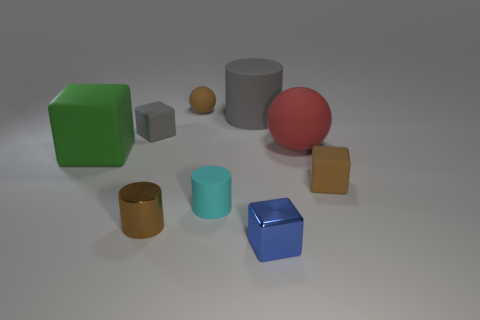Add 1 brown spheres. How many objects exist? 10 Subtract all blocks. How many objects are left? 5 Subtract all blue metallic blocks. Subtract all red objects. How many objects are left? 7 Add 5 large cylinders. How many large cylinders are left? 6 Add 5 yellow blocks. How many yellow blocks exist? 5 Subtract 0 blue cylinders. How many objects are left? 9 